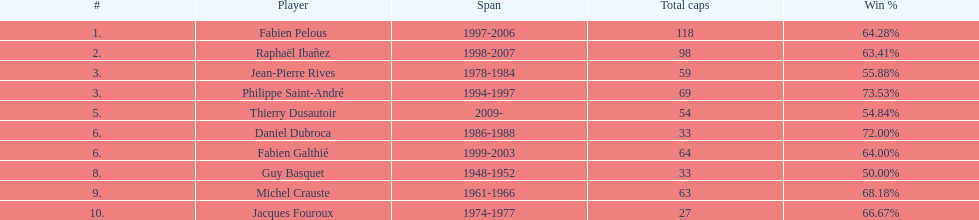Which player has the highest win percentage? Philippe Saint-André. 